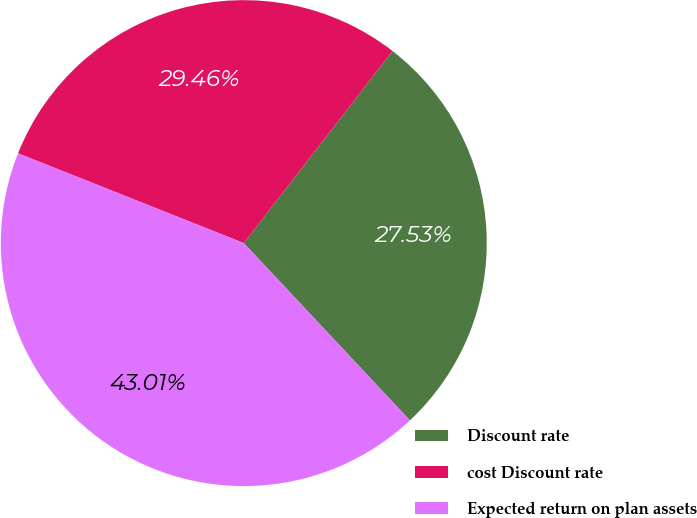<chart> <loc_0><loc_0><loc_500><loc_500><pie_chart><fcel>Discount rate<fcel>cost Discount rate<fcel>Expected return on plan assets<nl><fcel>27.53%<fcel>29.46%<fcel>43.01%<nl></chart> 